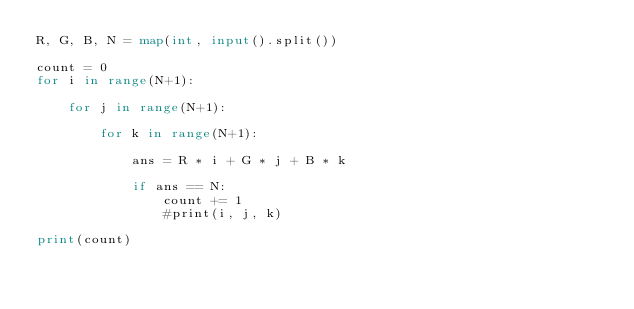<code> <loc_0><loc_0><loc_500><loc_500><_Python_>R, G, B, N = map(int, input().split())

count = 0
for i in range(N+1):
    
    for j in range(N+1):
        
        for k in range(N+1):
        
            ans = R * i + G * j + B * k
            
            if ans == N:
                count += 1
                #print(i, j, k)
            
print(count)</code> 